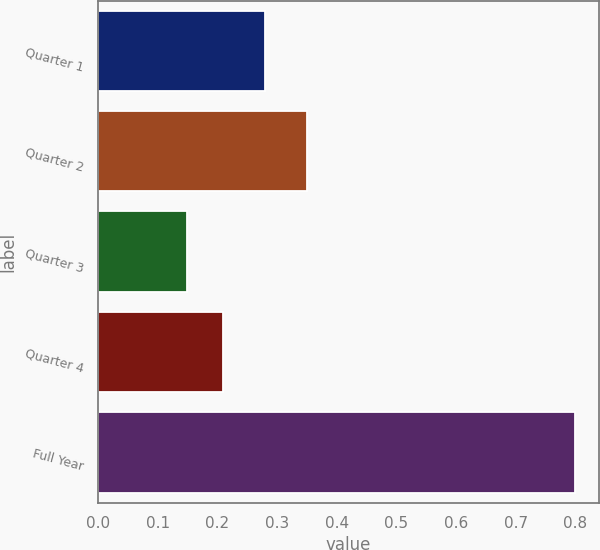<chart> <loc_0><loc_0><loc_500><loc_500><bar_chart><fcel>Quarter 1<fcel>Quarter 2<fcel>Quarter 3<fcel>Quarter 4<fcel>Full Year<nl><fcel>0.28<fcel>0.35<fcel>0.15<fcel>0.21<fcel>0.8<nl></chart> 